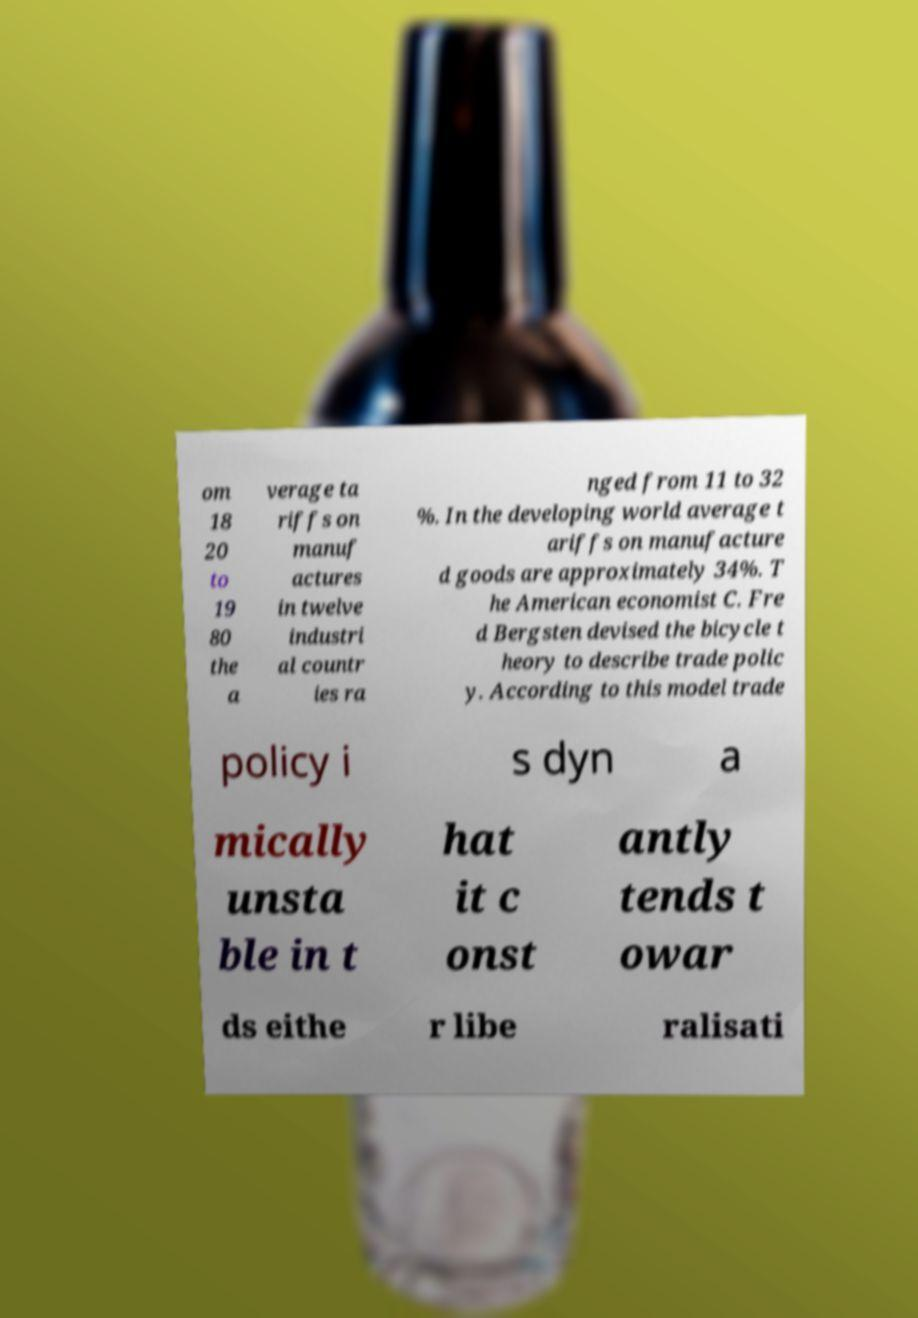Please identify and transcribe the text found in this image. om 18 20 to 19 80 the a verage ta riffs on manuf actures in twelve industri al countr ies ra nged from 11 to 32 %. In the developing world average t ariffs on manufacture d goods are approximately 34%. T he American economist C. Fre d Bergsten devised the bicycle t heory to describe trade polic y. According to this model trade policy i s dyn a mically unsta ble in t hat it c onst antly tends t owar ds eithe r libe ralisati 